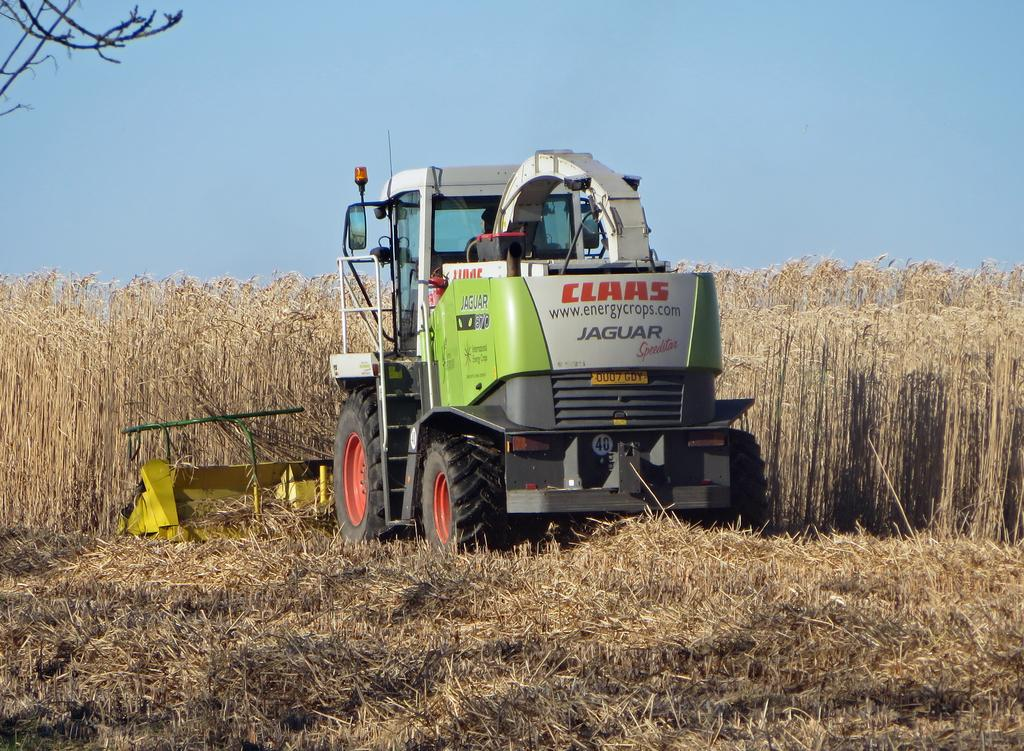What is the main subject of the image? The main subject of the image is a truck. What is attached to the truck? The truck has a grass cutting machine attached to it. What is the grass cutting machine doing? The grass cutting machine is cutting dry grass on the ground. What is the color of the sky in the image? The sky is blue in the image. Is there any smoke coming from the truck's exhaust in the image? There is no mention of smoke or the truck's exhaust in the provided facts, so we cannot determine if there is any smoke present in the image. 